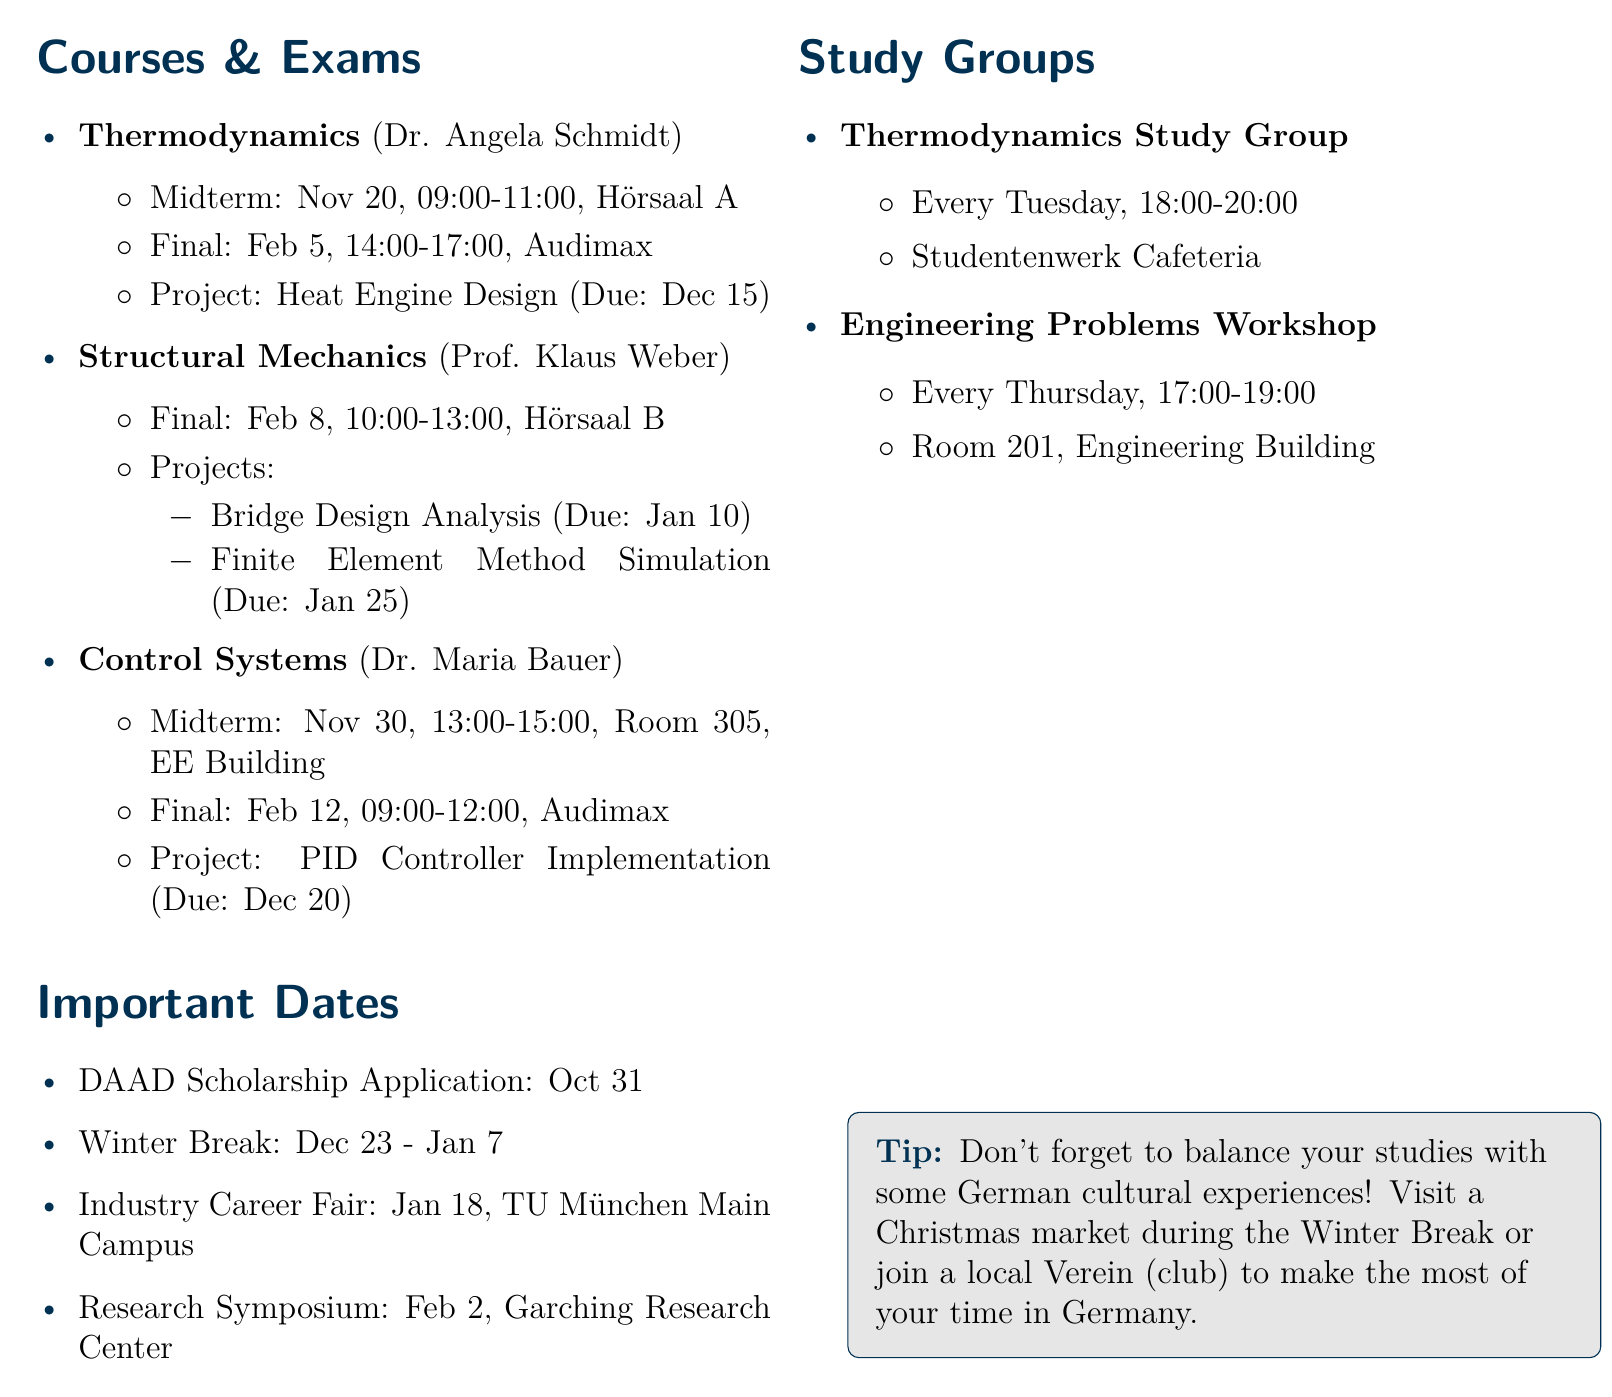What is the start date of the semester? The start date of the semester is explicitly mentioned in the document as October 1, 2023.
Answer: October 1, 2023 Who is the professor for Control Systems? The document lists Dr. Maria Bauer as the professor for the Control Systems course.
Answer: Dr. Maria Bauer When is the Final exam for Structural Mechanics? The document provides the date and time for the Final exam in Structural Mechanics, which is February 8, 2024.
Answer: February 8, 2024 What is the deadline for the Heat Engine Design project? The project deadline for Heat Engine Design is specifically stated as December 15, 2023 in the document.
Answer: December 15, 2023 How many projects are due for Structural Mechanics? The document mentions two projects due for Structural Mechanics, which are Bridge Design Analysis and Finite Element Method Simulation.
Answer: Two What event occurs after the Winter Break ends? The document lists the Industry Career Fair occurring on January 18, 2024, following the Winter Break.
Answer: Industry Career Fair What time is the Midterm exam for Thermodynamics? The time for the Midterm exam in Thermodynamics is given as 09:00 - 11:00.
Answer: 09:00 - 11:00 Which day does the Thermodynamics Study Group meet? The document states that the Thermodynamics Study Group meets every Tuesday.
Answer: Every Tuesday What is the location for the Research Symposium? The document specifies that the Research Symposium will take place at Garching Research Center.
Answer: Garching Research Center 